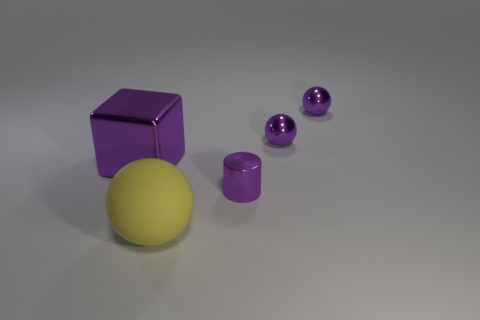Add 2 large purple blocks. How many objects exist? 7 Subtract all balls. How many objects are left? 2 Subtract 0 brown cubes. How many objects are left? 5 Subtract all cyan matte cylinders. Subtract all big shiny cubes. How many objects are left? 4 Add 5 big purple metallic objects. How many big purple metallic objects are left? 6 Add 5 yellow objects. How many yellow objects exist? 6 